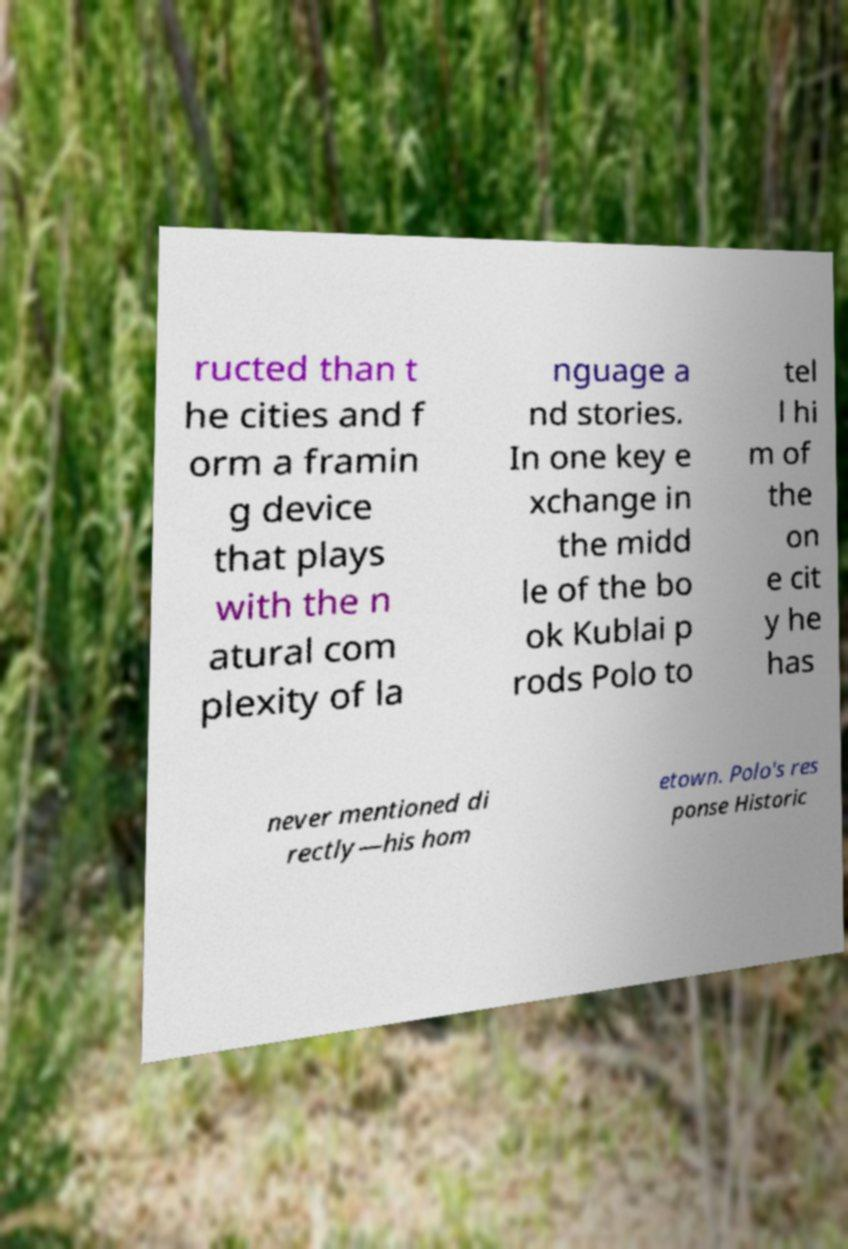For documentation purposes, I need the text within this image transcribed. Could you provide that? ructed than t he cities and f orm a framin g device that plays with the n atural com plexity of la nguage a nd stories. In one key e xchange in the midd le of the bo ok Kublai p rods Polo to tel l hi m of the on e cit y he has never mentioned di rectly—his hom etown. Polo's res ponse Historic 